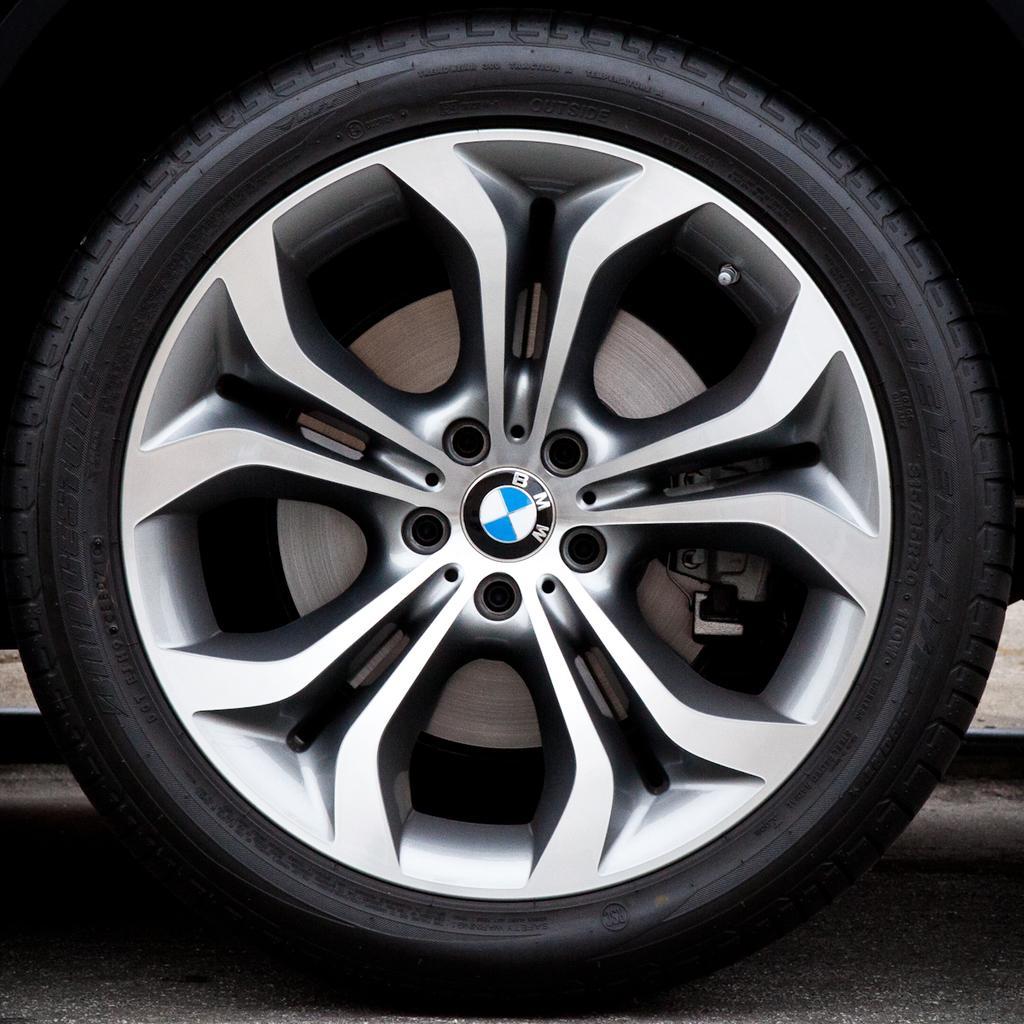Describe this image in one or two sentences. In this picture I can see a tyre, and a BMW logo on the rim of the tyre. 